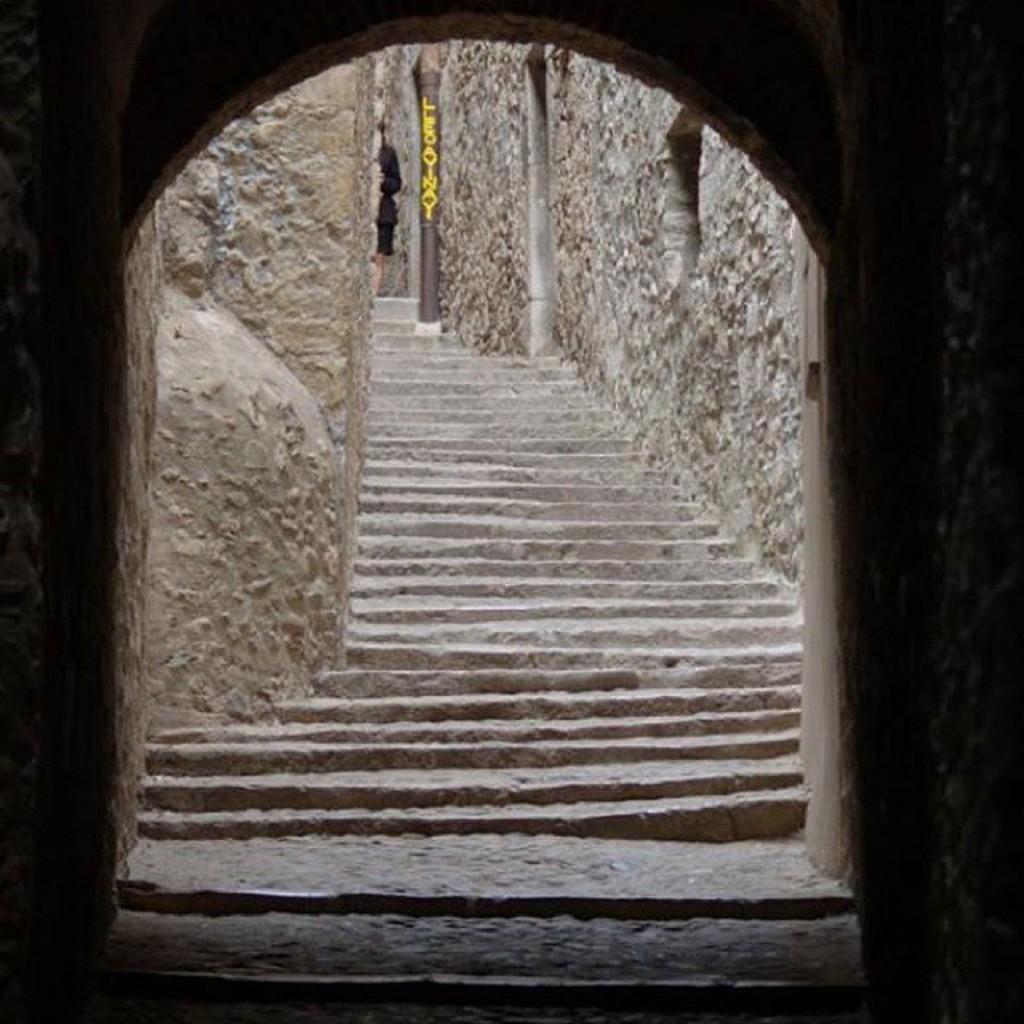How would you summarize this image in a sentence or two? In this picture I can see the staircase at the center. 